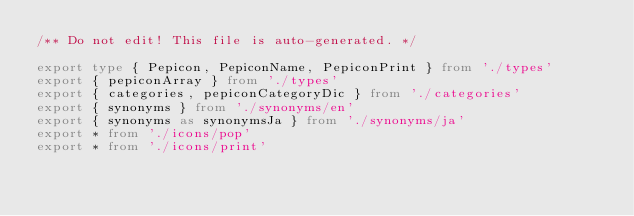Convert code to text. <code><loc_0><loc_0><loc_500><loc_500><_TypeScript_>/** Do not edit! This file is auto-generated. */

export type { Pepicon, PepiconName, PepiconPrint } from './types'
export { pepiconArray } from './types'
export { categories, pepiconCategoryDic } from './categories'
export { synonyms } from './synonyms/en'
export { synonyms as synonymsJa } from './synonyms/ja'
export * from './icons/pop'
export * from './icons/print'
</code> 